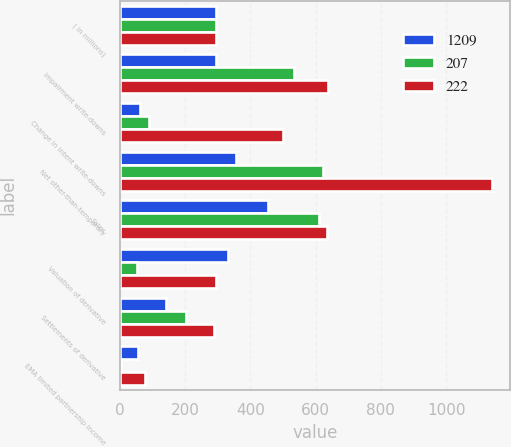<chart> <loc_0><loc_0><loc_500><loc_500><stacked_bar_chart><ecel><fcel>( in millions)<fcel>Impairment write-downs<fcel>Change in intent write-downs<fcel>Net other-than-temporary<fcel>Sales<fcel>Valuation of derivative<fcel>Settlements of derivative<fcel>EMA limited partnership income<nl><fcel>1209<fcel>296<fcel>295<fcel>62<fcel>357<fcel>455<fcel>331<fcel>143<fcel>55<nl><fcel>207<fcel>296<fcel>534<fcel>89<fcel>623<fcel>611<fcel>52<fcel>203<fcel>5<nl><fcel>222<fcel>296<fcel>638<fcel>501<fcel>1139<fcel>635<fcel>296<fcel>289<fcel>77<nl></chart> 